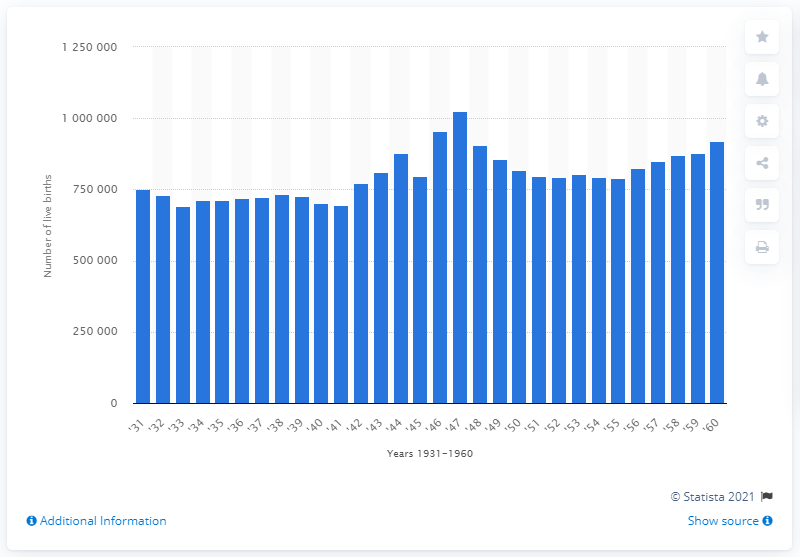Identify some key points in this picture. In the year 1941, a total of 695,726 births were recorded. 